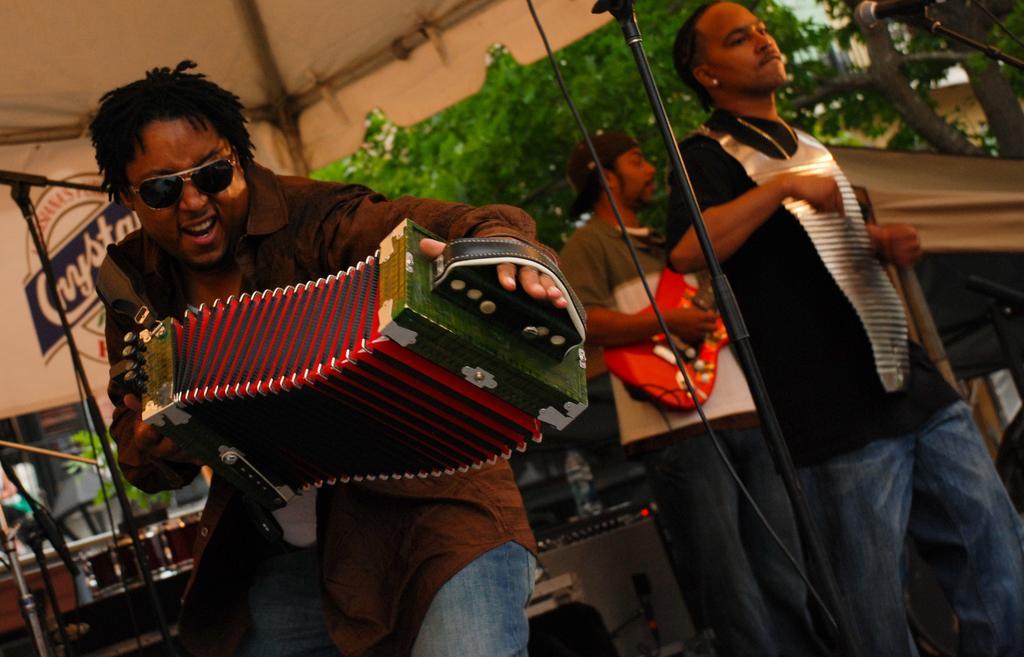Could you give a brief overview of what you see in this image? In this image, on the left side, we can see a man wearing a brown color shirt is playing a musical instrument. On the right side, we can see a microphone and two persons are playing a musical instrument in front of a microphone. In the background, we can see some trees, musical instrument, tents. 